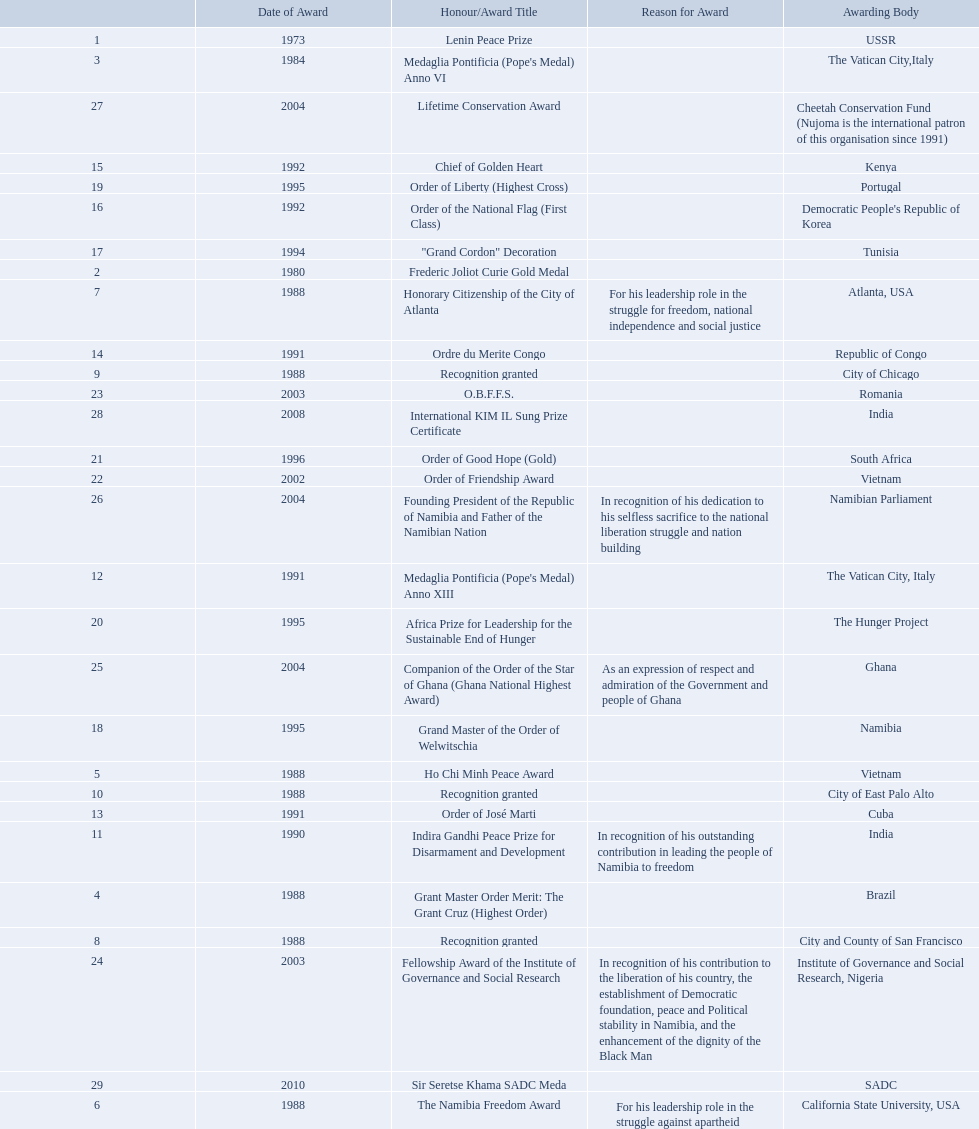What awards has sam nujoma been awarded? Lenin Peace Prize, Frederic Joliot Curie Gold Medal, Medaglia Pontificia (Pope's Medal) Anno VI, Grant Master Order Merit: The Grant Cruz (Highest Order), Ho Chi Minh Peace Award, The Namibia Freedom Award, Honorary Citizenship of the City of Atlanta, Recognition granted, Recognition granted, Recognition granted, Indira Gandhi Peace Prize for Disarmament and Development, Medaglia Pontificia (Pope's Medal) Anno XIII, Order of José Marti, Ordre du Merite Congo, Chief of Golden Heart, Order of the National Flag (First Class), "Grand Cordon" Decoration, Grand Master of the Order of Welwitschia, Order of Liberty (Highest Cross), Africa Prize for Leadership for the Sustainable End of Hunger, Order of Good Hope (Gold), Order of Friendship Award, O.B.F.F.S., Fellowship Award of the Institute of Governance and Social Research, Companion of the Order of the Star of Ghana (Ghana National Highest Award), Founding President of the Republic of Namibia and Father of the Namibian Nation, Lifetime Conservation Award, International KIM IL Sung Prize Certificate, Sir Seretse Khama SADC Meda. By which awarding body did sam nujoma receive the o.b.f.f.s award? Romania. 